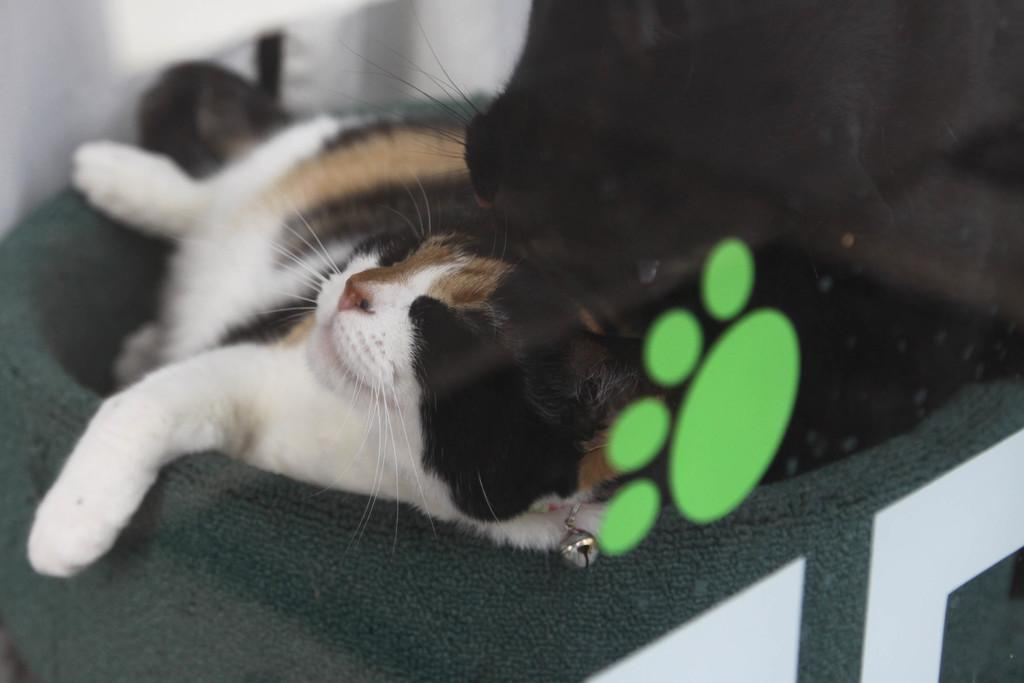How many cats are in the image? There are two cats in the image. What is located in the foreground of the image? There is a glass in the foreground of the image. What can be seen on the glass? The glass has a green color footprint on it. What type of pain is the cat experiencing in the image? There is no indication in the image that the cats are experiencing any pain. How are the cats sorting the objects in the image? The cats are not sorting any objects in the image; they are simply present in the scene. 